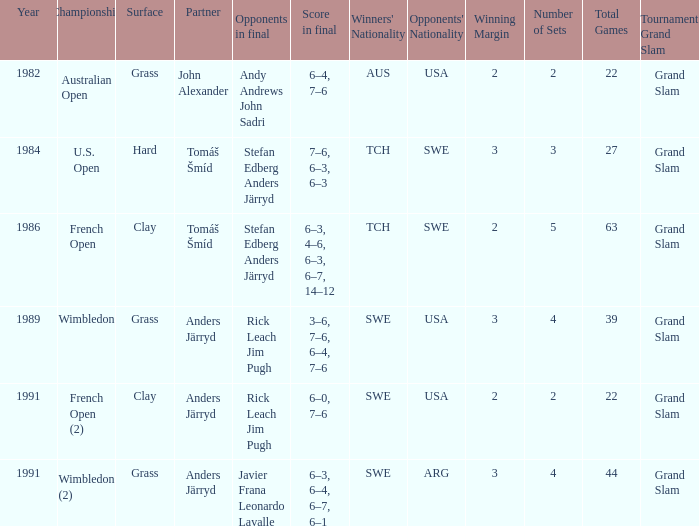What was the final score in 1986? 6–3, 4–6, 6–3, 6–7, 14–12. 